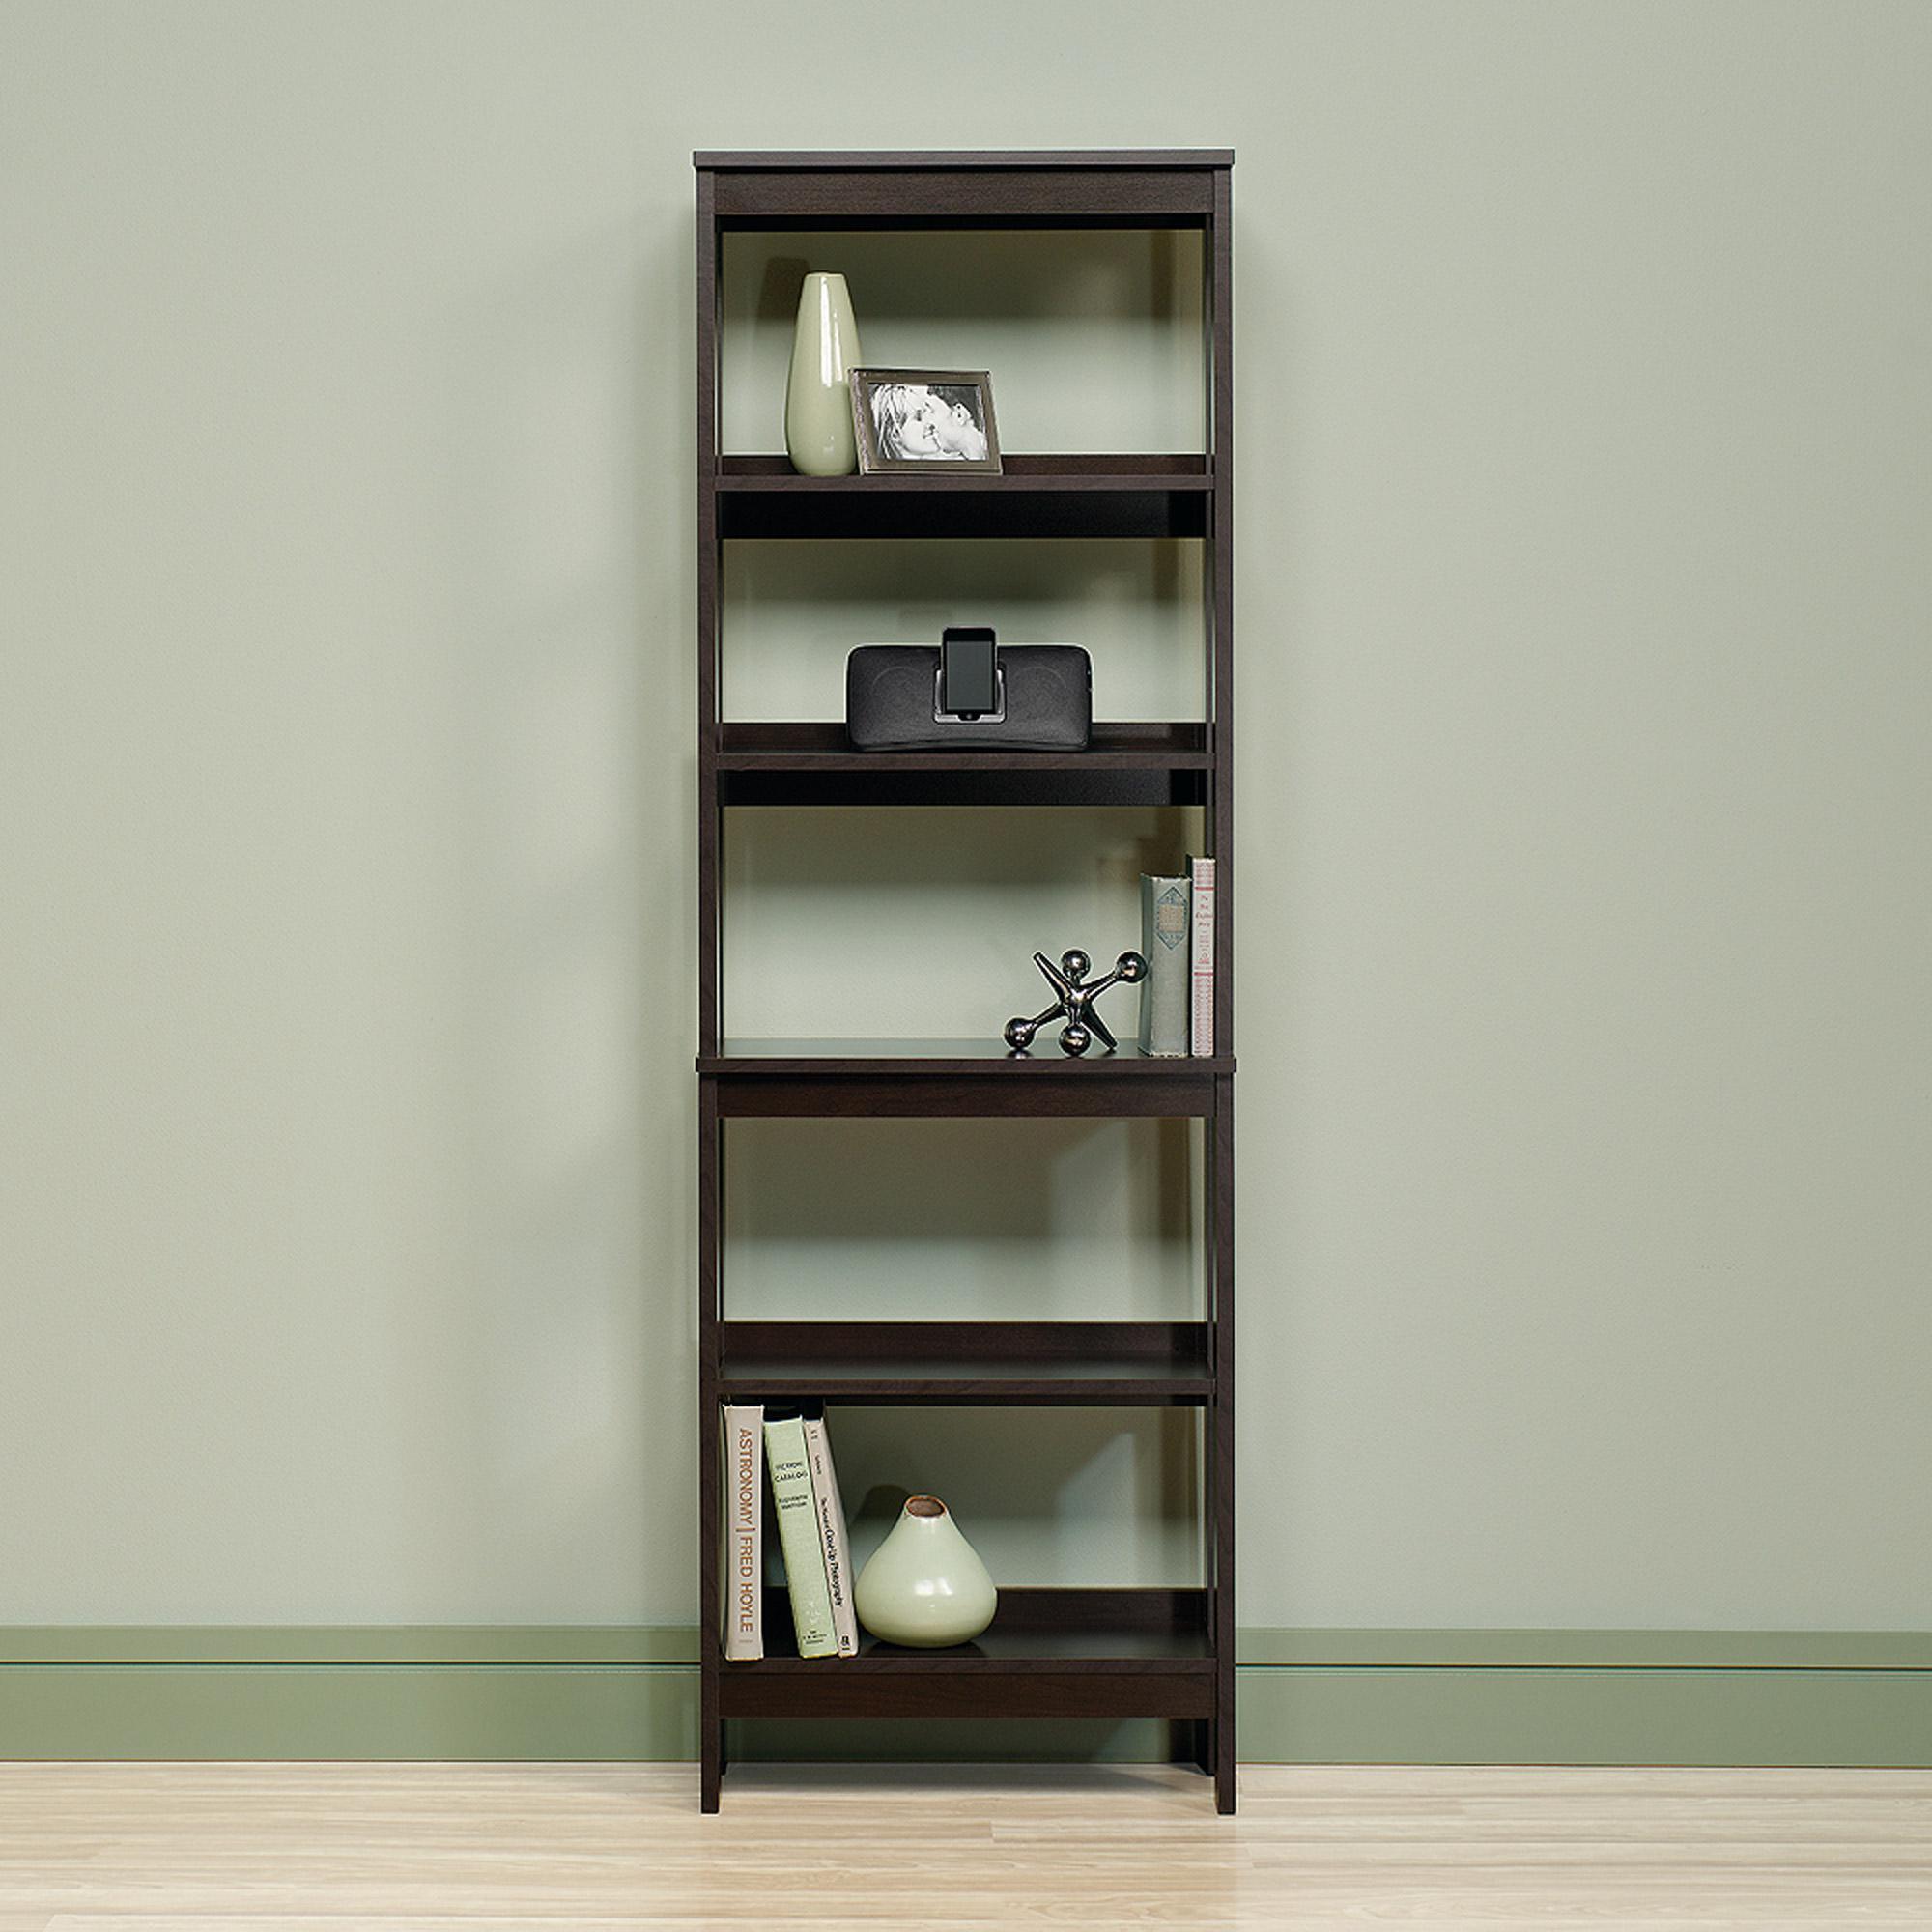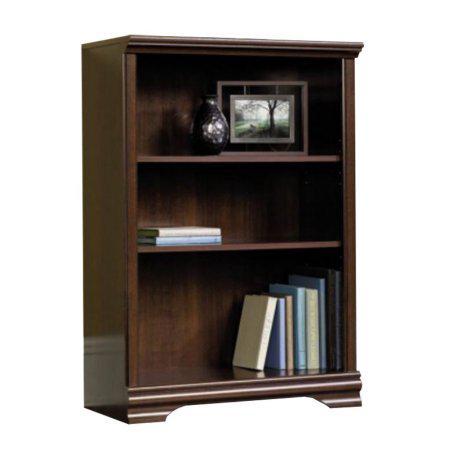The first image is the image on the left, the second image is the image on the right. Given the left and right images, does the statement "Both bookcases have three shelves." hold true? Answer yes or no. No. The first image is the image on the left, the second image is the image on the right. Evaluate the accuracy of this statement regarding the images: "Each bookcase has a solid back and exactly three shelves, and one bookcase has two items side-by-side on its top, while the other has an empty top.". Is it true? Answer yes or no. No. 